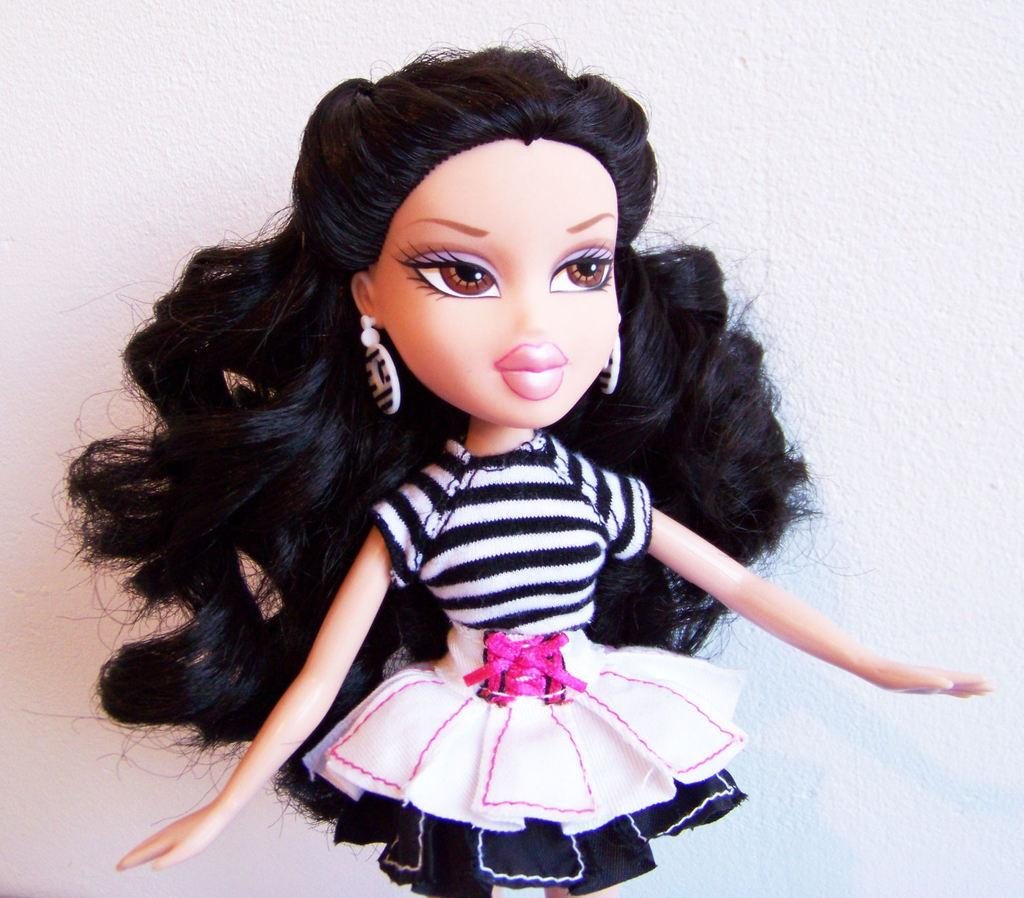What is the main subject in the image? There is a doll in the image. What color is the background of the image? The background of the image is white. Can you hear the doll whistling in the image? There is no sound in the image, so it is not possible to hear the doll whistling. 